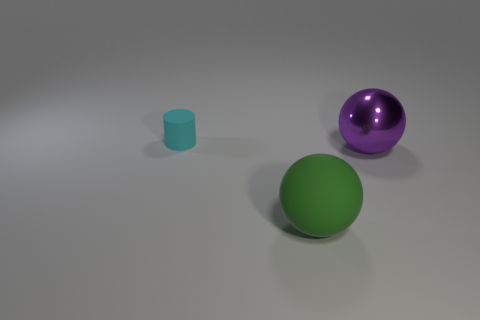Add 3 tiny matte things. How many objects exist? 6 Subtract 0 red cubes. How many objects are left? 3 Subtract all balls. How many objects are left? 1 Subtract all small cyan objects. Subtract all tiny cyan cylinders. How many objects are left? 1 Add 3 tiny matte cylinders. How many tiny matte cylinders are left? 4 Add 3 big spheres. How many big spheres exist? 5 